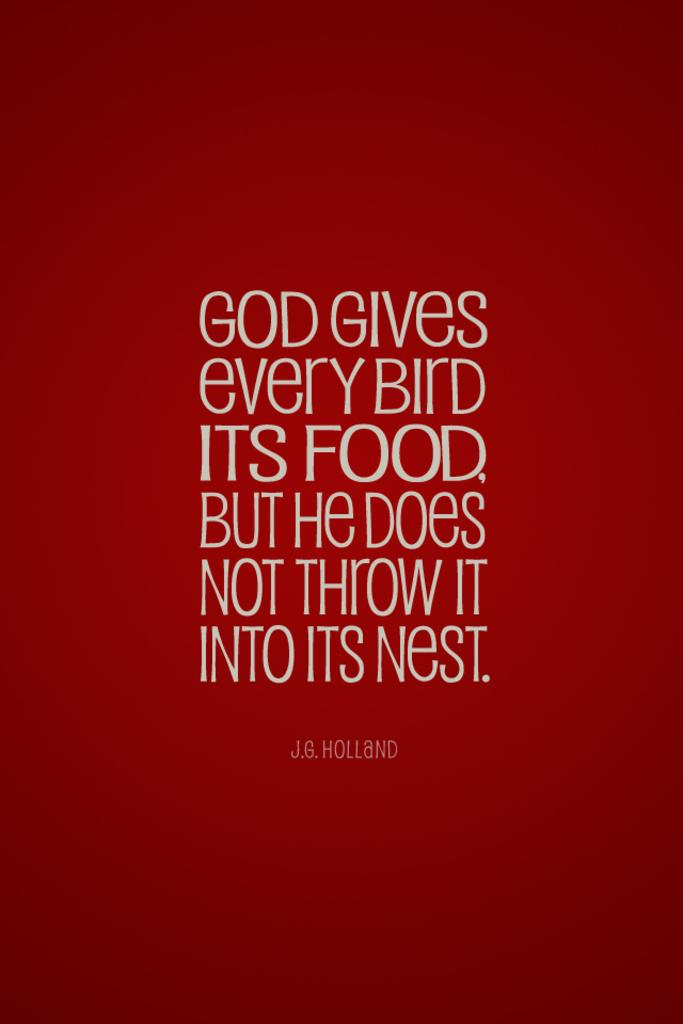Provide a one-sentence caption for the provided image. a red graphic with text saying 'god gives every bird its food, but he does not throw it into its nest.'. 